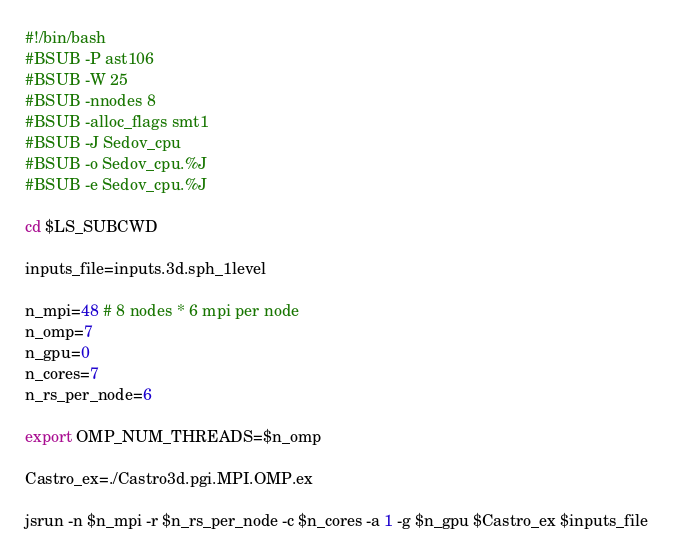Convert code to text. <code><loc_0><loc_0><loc_500><loc_500><_Bash_>#!/bin/bash
#BSUB -P ast106
#BSUB -W 25
#BSUB -nnodes 8
#BSUB -alloc_flags smt1
#BSUB -J Sedov_cpu
#BSUB -o Sedov_cpu.%J
#BSUB -e Sedov_cpu.%J

cd $LS_SUBCWD

inputs_file=inputs.3d.sph_1level  

n_mpi=48 # 8 nodes * 6 mpi per node
n_omp=7
n_gpu=0
n_cores=7
n_rs_per_node=6

export OMP_NUM_THREADS=$n_omp

Castro_ex=./Castro3d.pgi.MPI.OMP.ex

jsrun -n $n_mpi -r $n_rs_per_node -c $n_cores -a 1 -g $n_gpu $Castro_ex $inputs_file
</code> 